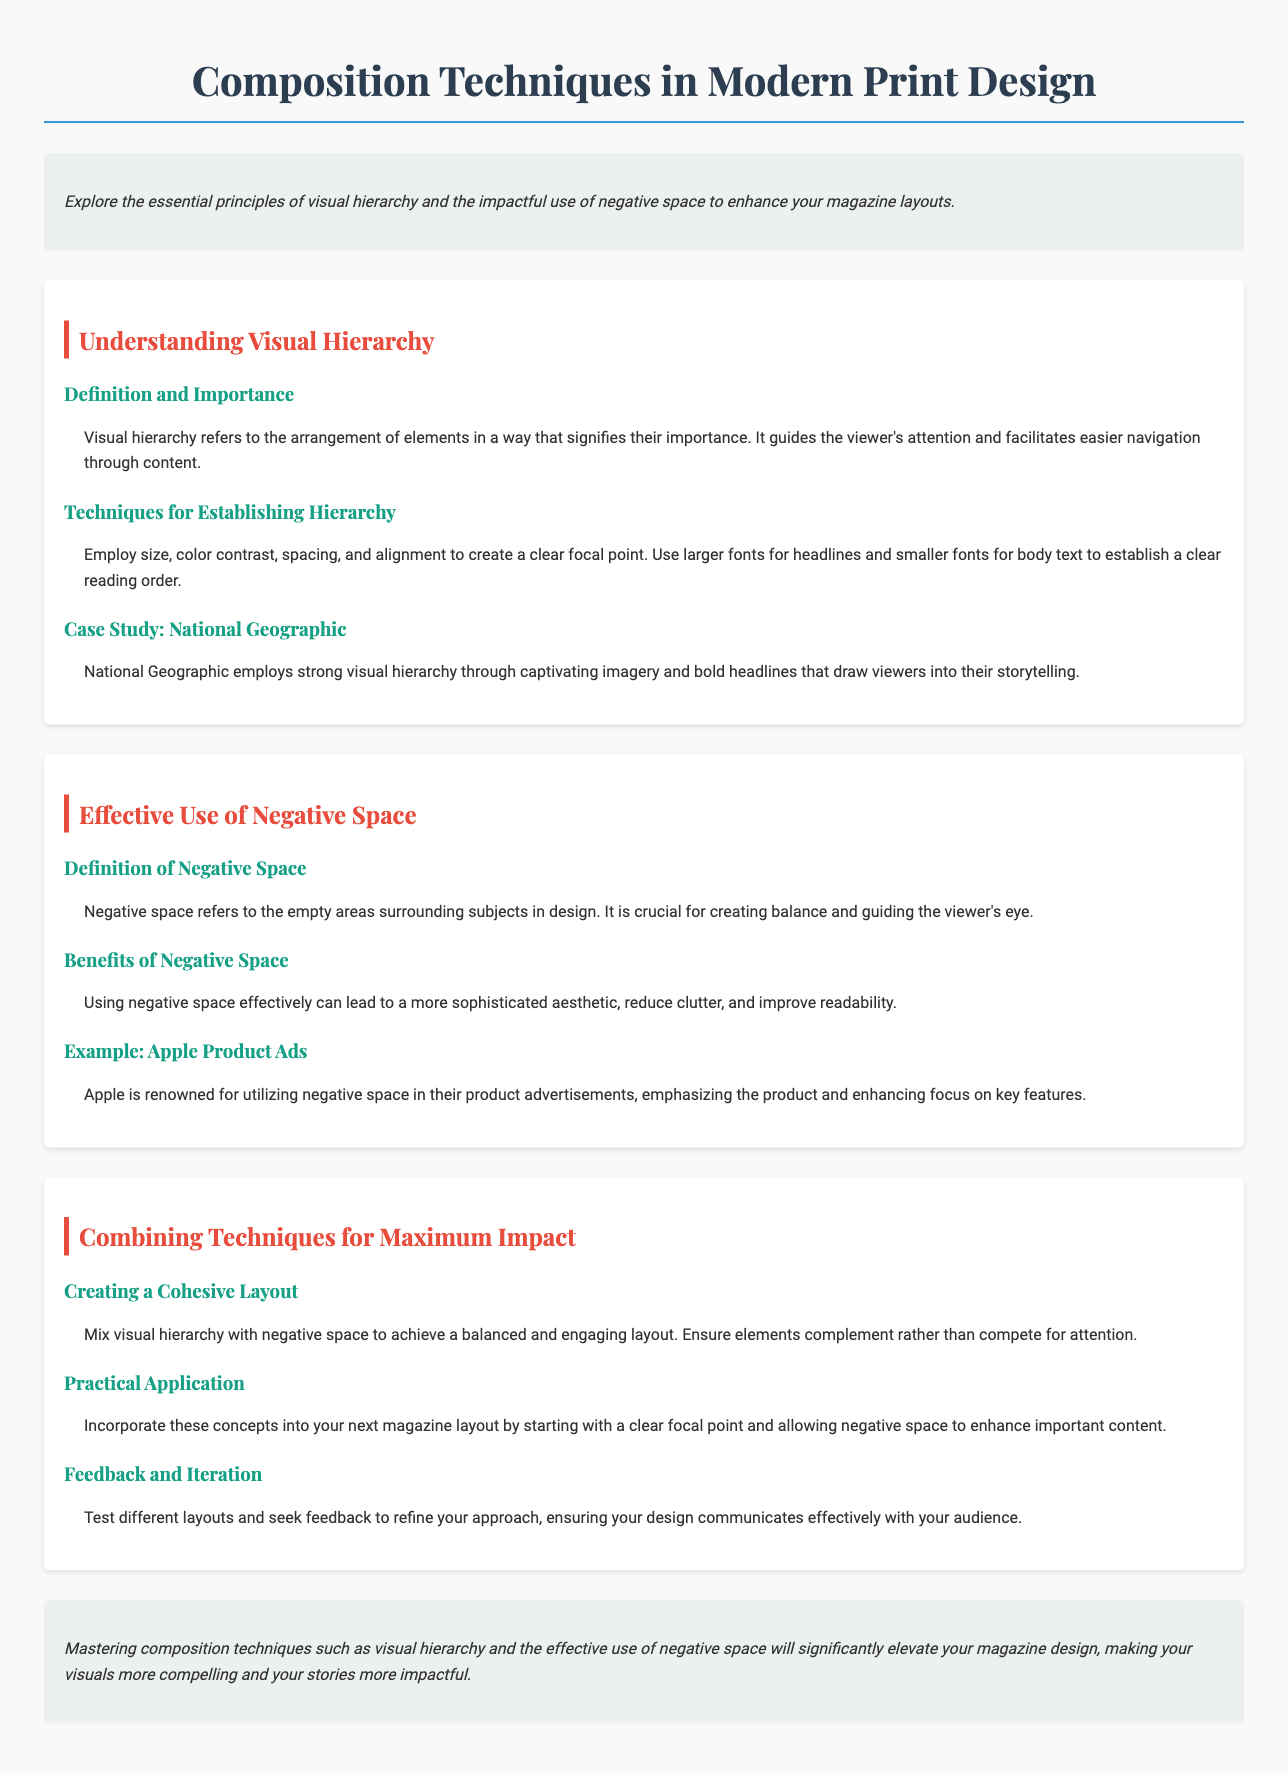What is the title of the document? The title of the document is specified in the <title> tag, which indicates the focus of the agenda.
Answer: Composition Techniques in Modern Print Design What is visual hierarchy? Visual hierarchy is defined in the document as the arrangement of elements that signifies their importance and guides viewer attention.
Answer: Arrangement of elements What color is used for section headings? The color for section headings is defined in the CSS, and is also mentioned in the visual styling section.
Answer: Red Which magazine is used as a case study for visual hierarchy? The case study selected for visual hierarchy is explicitly mentioned under that section in the document.
Answer: National Geographic What does negative space refer to? Negative space is defined in the document as the empty areas surrounding subjects in design.
Answer: Empty areas What is one benefit of using negative space? The document mentions several advantages of negative space usage, focusing on its contribution to overall design quality.
Answer: Improved readability What is the key point for creating a cohesive layout? The document presents practical advice for achieving cohesion by integrating certain design concepts.
Answer: Mix visual hierarchy with negative space What is suggested for practical application in layouts? The practical application guidance provided in the document emphasizes starting with a specific design element.
Answer: Clear focal point How should feedback be utilized in the design process? The document advises that feedback is essential for refining design approaches and enhances communication with the audience.
Answer: Seek feedback 